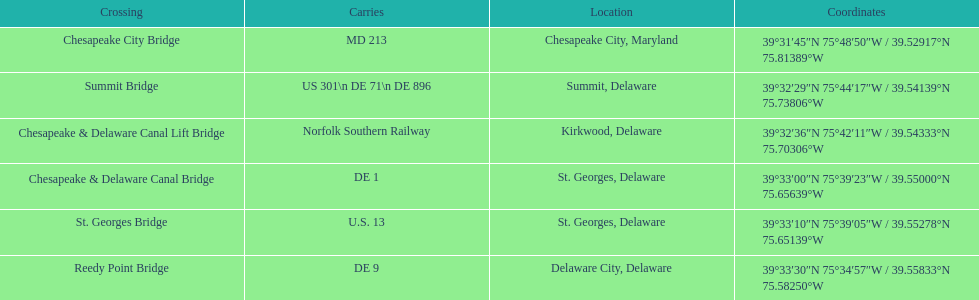Which bridge is in delaware and carries de 9? Reedy Point Bridge. 